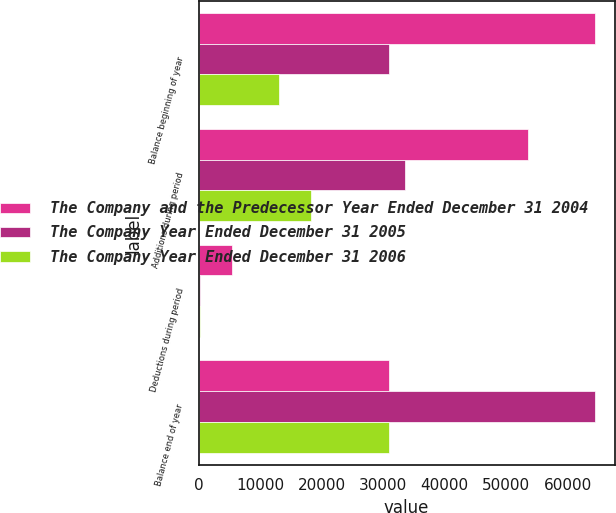Convert chart to OTSL. <chart><loc_0><loc_0><loc_500><loc_500><stacked_bar_chart><ecel><fcel>Balance beginning of year<fcel>Additions during period<fcel>Deductions during period<fcel>Balance end of year<nl><fcel>The Company and the Predecessor Year Ended December 31 2004<fcel>64404<fcel>53478<fcel>5403<fcel>30980<nl><fcel>The Company Year Ended December 31 2005<fcel>30980<fcel>33626<fcel>202<fcel>64404<nl><fcel>The Company Year Ended December 31 2006<fcel>13026<fcel>18207<fcel>253<fcel>30980<nl></chart> 